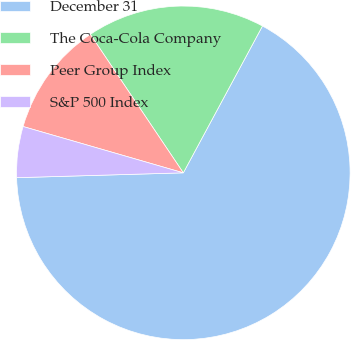Convert chart to OTSL. <chart><loc_0><loc_0><loc_500><loc_500><pie_chart><fcel>December 31<fcel>The Coca-Cola Company<fcel>Peer Group Index<fcel>S&P 500 Index<nl><fcel>66.66%<fcel>17.28%<fcel>11.11%<fcel>4.94%<nl></chart> 